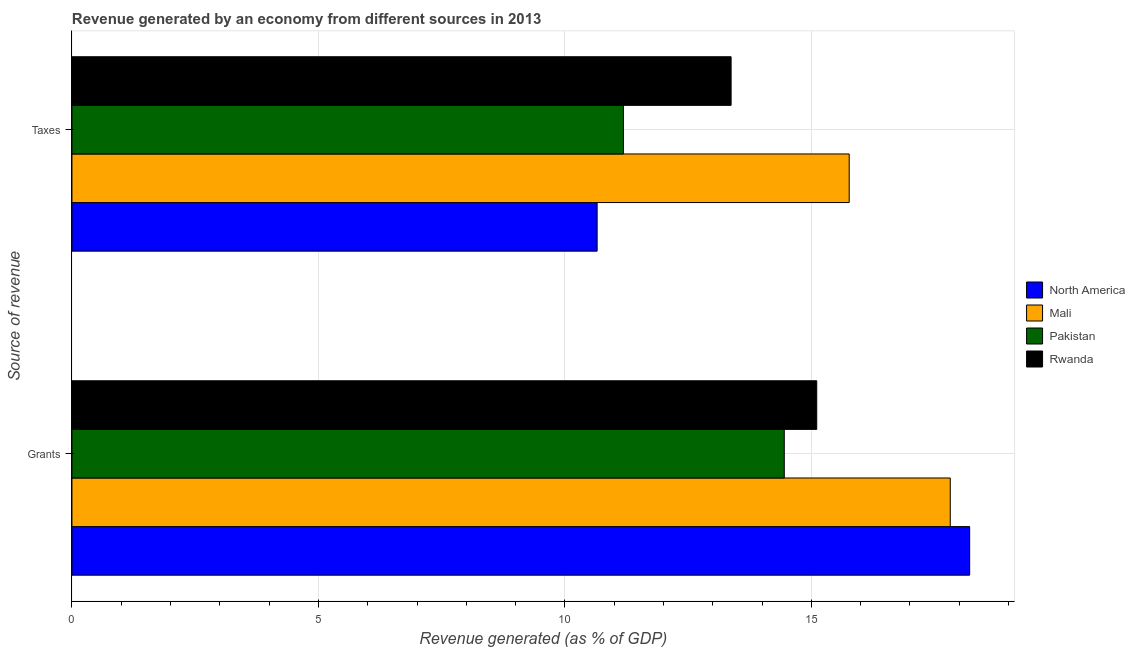How many different coloured bars are there?
Provide a succinct answer. 4. Are the number of bars per tick equal to the number of legend labels?
Make the answer very short. Yes. How many bars are there on the 2nd tick from the top?
Provide a short and direct response. 4. What is the label of the 1st group of bars from the top?
Provide a succinct answer. Taxes. What is the revenue generated by grants in Mali?
Provide a short and direct response. 17.82. Across all countries, what is the maximum revenue generated by grants?
Keep it short and to the point. 18.21. Across all countries, what is the minimum revenue generated by grants?
Provide a short and direct response. 14.45. In which country was the revenue generated by grants maximum?
Offer a very short reply. North America. What is the total revenue generated by taxes in the graph?
Your answer should be compact. 50.98. What is the difference between the revenue generated by taxes in Pakistan and that in Mali?
Your answer should be very brief. -4.58. What is the difference between the revenue generated by grants in Mali and the revenue generated by taxes in North America?
Ensure brevity in your answer.  7.16. What is the average revenue generated by taxes per country?
Ensure brevity in your answer.  12.75. What is the difference between the revenue generated by grants and revenue generated by taxes in Rwanda?
Offer a very short reply. 1.74. What is the ratio of the revenue generated by taxes in North America to that in Pakistan?
Your response must be concise. 0.95. Is the revenue generated by taxes in North America less than that in Mali?
Offer a very short reply. Yes. What does the 1st bar from the top in Taxes represents?
Ensure brevity in your answer.  Rwanda. What does the 4th bar from the bottom in Grants represents?
Offer a terse response. Rwanda. Where does the legend appear in the graph?
Ensure brevity in your answer.  Center right. How are the legend labels stacked?
Make the answer very short. Vertical. What is the title of the graph?
Make the answer very short. Revenue generated by an economy from different sources in 2013. What is the label or title of the X-axis?
Offer a very short reply. Revenue generated (as % of GDP). What is the label or title of the Y-axis?
Give a very brief answer. Source of revenue. What is the Revenue generated (as % of GDP) of North America in Grants?
Provide a succinct answer. 18.21. What is the Revenue generated (as % of GDP) in Mali in Grants?
Your answer should be compact. 17.82. What is the Revenue generated (as % of GDP) of Pakistan in Grants?
Offer a terse response. 14.45. What is the Revenue generated (as % of GDP) in Rwanda in Grants?
Provide a short and direct response. 15.11. What is the Revenue generated (as % of GDP) in North America in Taxes?
Give a very brief answer. 10.65. What is the Revenue generated (as % of GDP) of Mali in Taxes?
Your response must be concise. 15.77. What is the Revenue generated (as % of GDP) of Pakistan in Taxes?
Your answer should be very brief. 11.19. What is the Revenue generated (as % of GDP) in Rwanda in Taxes?
Your answer should be compact. 13.37. Across all Source of revenue, what is the maximum Revenue generated (as % of GDP) in North America?
Offer a terse response. 18.21. Across all Source of revenue, what is the maximum Revenue generated (as % of GDP) in Mali?
Keep it short and to the point. 17.82. Across all Source of revenue, what is the maximum Revenue generated (as % of GDP) of Pakistan?
Make the answer very short. 14.45. Across all Source of revenue, what is the maximum Revenue generated (as % of GDP) in Rwanda?
Provide a short and direct response. 15.11. Across all Source of revenue, what is the minimum Revenue generated (as % of GDP) in North America?
Ensure brevity in your answer.  10.65. Across all Source of revenue, what is the minimum Revenue generated (as % of GDP) in Mali?
Give a very brief answer. 15.77. Across all Source of revenue, what is the minimum Revenue generated (as % of GDP) in Pakistan?
Give a very brief answer. 11.19. Across all Source of revenue, what is the minimum Revenue generated (as % of GDP) in Rwanda?
Offer a terse response. 13.37. What is the total Revenue generated (as % of GDP) in North America in the graph?
Give a very brief answer. 28.87. What is the total Revenue generated (as % of GDP) of Mali in the graph?
Keep it short and to the point. 33.59. What is the total Revenue generated (as % of GDP) of Pakistan in the graph?
Your answer should be compact. 25.64. What is the total Revenue generated (as % of GDP) in Rwanda in the graph?
Provide a succinct answer. 28.48. What is the difference between the Revenue generated (as % of GDP) in North America in Grants and that in Taxes?
Provide a short and direct response. 7.56. What is the difference between the Revenue generated (as % of GDP) in Mali in Grants and that in Taxes?
Your answer should be compact. 2.05. What is the difference between the Revenue generated (as % of GDP) of Pakistan in Grants and that in Taxes?
Give a very brief answer. 3.26. What is the difference between the Revenue generated (as % of GDP) in Rwanda in Grants and that in Taxes?
Provide a short and direct response. 1.74. What is the difference between the Revenue generated (as % of GDP) of North America in Grants and the Revenue generated (as % of GDP) of Mali in Taxes?
Make the answer very short. 2.44. What is the difference between the Revenue generated (as % of GDP) of North America in Grants and the Revenue generated (as % of GDP) of Pakistan in Taxes?
Give a very brief answer. 7.02. What is the difference between the Revenue generated (as % of GDP) in North America in Grants and the Revenue generated (as % of GDP) in Rwanda in Taxes?
Your answer should be very brief. 4.84. What is the difference between the Revenue generated (as % of GDP) in Mali in Grants and the Revenue generated (as % of GDP) in Pakistan in Taxes?
Your answer should be compact. 6.63. What is the difference between the Revenue generated (as % of GDP) in Mali in Grants and the Revenue generated (as % of GDP) in Rwanda in Taxes?
Your answer should be compact. 4.45. What is the difference between the Revenue generated (as % of GDP) in Pakistan in Grants and the Revenue generated (as % of GDP) in Rwanda in Taxes?
Give a very brief answer. 1.08. What is the average Revenue generated (as % of GDP) of North America per Source of revenue?
Make the answer very short. 14.43. What is the average Revenue generated (as % of GDP) in Mali per Source of revenue?
Make the answer very short. 16.79. What is the average Revenue generated (as % of GDP) in Pakistan per Source of revenue?
Give a very brief answer. 12.82. What is the average Revenue generated (as % of GDP) in Rwanda per Source of revenue?
Give a very brief answer. 14.24. What is the difference between the Revenue generated (as % of GDP) of North America and Revenue generated (as % of GDP) of Mali in Grants?
Your answer should be compact. 0.39. What is the difference between the Revenue generated (as % of GDP) of North America and Revenue generated (as % of GDP) of Pakistan in Grants?
Offer a very short reply. 3.76. What is the difference between the Revenue generated (as % of GDP) in North America and Revenue generated (as % of GDP) in Rwanda in Grants?
Give a very brief answer. 3.1. What is the difference between the Revenue generated (as % of GDP) in Mali and Revenue generated (as % of GDP) in Pakistan in Grants?
Make the answer very short. 3.37. What is the difference between the Revenue generated (as % of GDP) in Mali and Revenue generated (as % of GDP) in Rwanda in Grants?
Your answer should be very brief. 2.71. What is the difference between the Revenue generated (as % of GDP) of Pakistan and Revenue generated (as % of GDP) of Rwanda in Grants?
Your answer should be very brief. -0.66. What is the difference between the Revenue generated (as % of GDP) in North America and Revenue generated (as % of GDP) in Mali in Taxes?
Your answer should be compact. -5.11. What is the difference between the Revenue generated (as % of GDP) of North America and Revenue generated (as % of GDP) of Pakistan in Taxes?
Your response must be concise. -0.53. What is the difference between the Revenue generated (as % of GDP) in North America and Revenue generated (as % of GDP) in Rwanda in Taxes?
Make the answer very short. -2.72. What is the difference between the Revenue generated (as % of GDP) in Mali and Revenue generated (as % of GDP) in Pakistan in Taxes?
Your answer should be compact. 4.58. What is the difference between the Revenue generated (as % of GDP) of Mali and Revenue generated (as % of GDP) of Rwanda in Taxes?
Offer a terse response. 2.4. What is the difference between the Revenue generated (as % of GDP) in Pakistan and Revenue generated (as % of GDP) in Rwanda in Taxes?
Provide a short and direct response. -2.18. What is the ratio of the Revenue generated (as % of GDP) of North America in Grants to that in Taxes?
Provide a short and direct response. 1.71. What is the ratio of the Revenue generated (as % of GDP) in Mali in Grants to that in Taxes?
Your answer should be very brief. 1.13. What is the ratio of the Revenue generated (as % of GDP) of Pakistan in Grants to that in Taxes?
Give a very brief answer. 1.29. What is the ratio of the Revenue generated (as % of GDP) of Rwanda in Grants to that in Taxes?
Your answer should be very brief. 1.13. What is the difference between the highest and the second highest Revenue generated (as % of GDP) of North America?
Ensure brevity in your answer.  7.56. What is the difference between the highest and the second highest Revenue generated (as % of GDP) of Mali?
Your answer should be very brief. 2.05. What is the difference between the highest and the second highest Revenue generated (as % of GDP) in Pakistan?
Provide a short and direct response. 3.26. What is the difference between the highest and the second highest Revenue generated (as % of GDP) of Rwanda?
Provide a short and direct response. 1.74. What is the difference between the highest and the lowest Revenue generated (as % of GDP) in North America?
Offer a terse response. 7.56. What is the difference between the highest and the lowest Revenue generated (as % of GDP) in Mali?
Give a very brief answer. 2.05. What is the difference between the highest and the lowest Revenue generated (as % of GDP) in Pakistan?
Ensure brevity in your answer.  3.26. What is the difference between the highest and the lowest Revenue generated (as % of GDP) in Rwanda?
Provide a short and direct response. 1.74. 